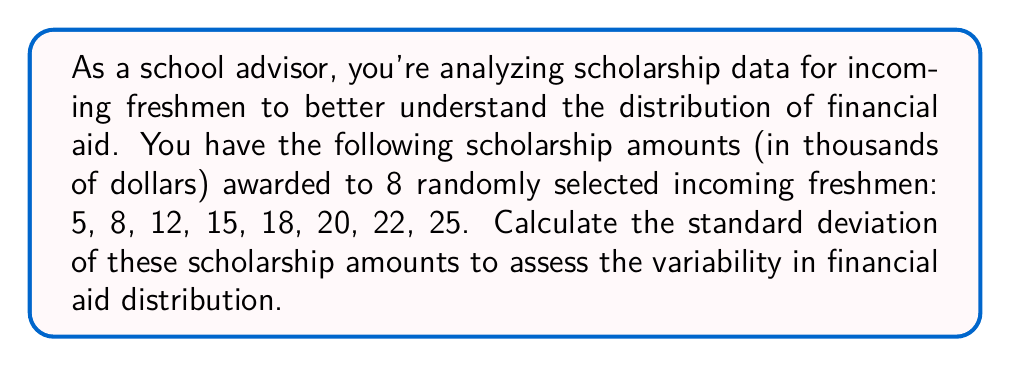Help me with this question. To calculate the standard deviation, we'll follow these steps:

1. Calculate the mean ($\mu$) of the scholarship amounts:
   $$\mu = \frac{5 + 8 + 12 + 15 + 18 + 20 + 22 + 25}{8} = \frac{125}{8} = 15.625$$

2. Calculate the squared differences from the mean:
   $$(5 - 15.625)^2 = (-10.625)^2 = 112.890625$$
   $$(8 - 15.625)^2 = (-7.625)^2 = 58.140625$$
   $$(12 - 15.625)^2 = (-3.625)^2 = 13.140625$$
   $$(15 - 15.625)^2 = (-0.625)^2 = 0.390625$$
   $$(18 - 15.625)^2 = (2.375)^2 = 5.640625$$
   $$(20 - 15.625)^2 = (4.375)^2 = 19.140625$$
   $$(22 - 15.625)^2 = (6.375)^2 = 40.640625$$
   $$(25 - 15.625)^2 = (9.375)^2 = 87.890625$$

3. Calculate the variance ($\sigma^2$) by finding the mean of these squared differences:
   $$\sigma^2 = \frac{112.890625 + 58.140625 + 13.140625 + 0.390625 + 5.640625 + 19.140625 + 40.640625 + 87.890625}{8}$$
   $$\sigma^2 = \frac{337.875}{8} = 42.234375$$

4. Calculate the standard deviation ($\sigma$) by taking the square root of the variance:
   $$\sigma = \sqrt{42.234375} \approx 6.498$$

Therefore, the standard deviation of the scholarship amounts is approximately 6.498 thousand dollars, or $6,498.
Answer: $6,498 